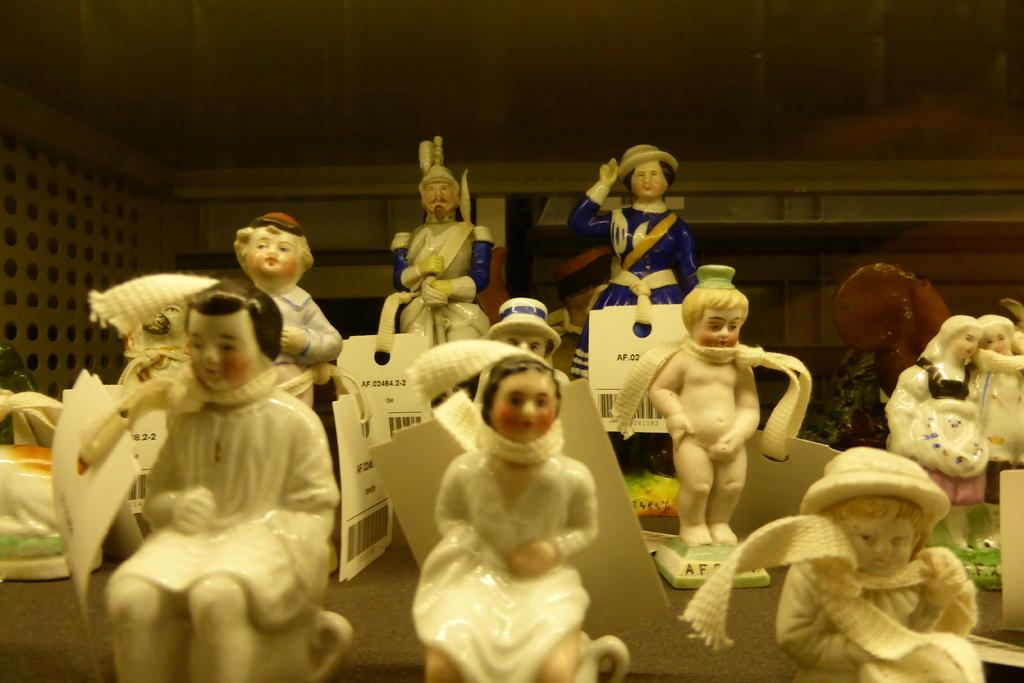What objects can be seen in the image? There are toys in the image. What additional features do the toys have? The toys have tags. How many clocks are visible in the image? There are no clocks present in the image; it features toys with tags. What type of garden can be seen in the image? There is no garden present in the image; it features toys with tags. 